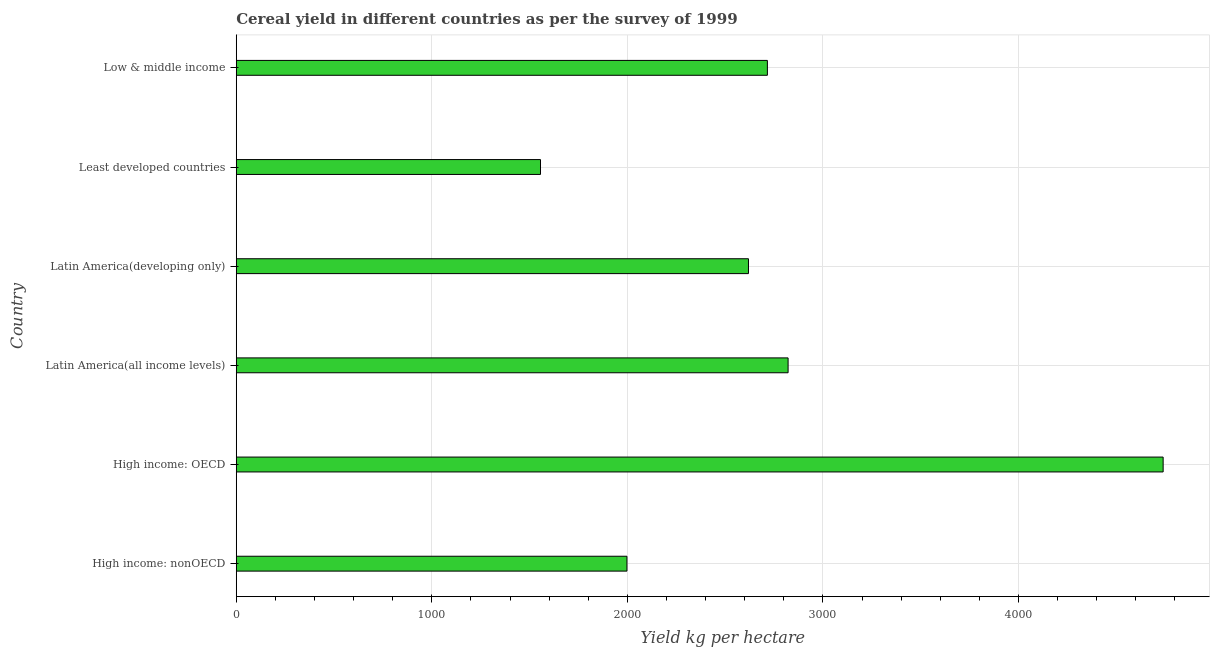What is the title of the graph?
Give a very brief answer. Cereal yield in different countries as per the survey of 1999. What is the label or title of the X-axis?
Your answer should be compact. Yield kg per hectare. What is the cereal yield in Latin America(developing only)?
Your response must be concise. 2619.43. Across all countries, what is the maximum cereal yield?
Ensure brevity in your answer.  4740.07. Across all countries, what is the minimum cereal yield?
Give a very brief answer. 1555.91. In which country was the cereal yield maximum?
Your answer should be very brief. High income: OECD. In which country was the cereal yield minimum?
Your answer should be very brief. Least developed countries. What is the sum of the cereal yield?
Your response must be concise. 1.65e+04. What is the difference between the cereal yield in High income: nonOECD and Latin America(developing only)?
Your response must be concise. -621.42. What is the average cereal yield per country?
Offer a terse response. 2741.94. What is the median cereal yield?
Ensure brevity in your answer.  2667.79. What is the ratio of the cereal yield in High income: OECD to that in High income: nonOECD?
Provide a short and direct response. 2.37. Is the difference between the cereal yield in Latin America(all income levels) and Least developed countries greater than the difference between any two countries?
Give a very brief answer. No. What is the difference between the highest and the second highest cereal yield?
Your response must be concise. 1917.99. What is the difference between the highest and the lowest cereal yield?
Provide a succinct answer. 3184.15. In how many countries, is the cereal yield greater than the average cereal yield taken over all countries?
Make the answer very short. 2. What is the difference between two consecutive major ticks on the X-axis?
Provide a succinct answer. 1000. Are the values on the major ticks of X-axis written in scientific E-notation?
Offer a terse response. No. What is the Yield kg per hectare in High income: nonOECD?
Provide a succinct answer. 1998.01. What is the Yield kg per hectare of High income: OECD?
Provide a succinct answer. 4740.07. What is the Yield kg per hectare in Latin America(all income levels)?
Provide a short and direct response. 2822.08. What is the Yield kg per hectare in Latin America(developing only)?
Keep it short and to the point. 2619.43. What is the Yield kg per hectare in Least developed countries?
Provide a succinct answer. 1555.91. What is the Yield kg per hectare of Low & middle income?
Your answer should be compact. 2716.16. What is the difference between the Yield kg per hectare in High income: nonOECD and High income: OECD?
Keep it short and to the point. -2742.06. What is the difference between the Yield kg per hectare in High income: nonOECD and Latin America(all income levels)?
Keep it short and to the point. -824.07. What is the difference between the Yield kg per hectare in High income: nonOECD and Latin America(developing only)?
Offer a terse response. -621.42. What is the difference between the Yield kg per hectare in High income: nonOECD and Least developed countries?
Offer a terse response. 442.09. What is the difference between the Yield kg per hectare in High income: nonOECD and Low & middle income?
Offer a terse response. -718.15. What is the difference between the Yield kg per hectare in High income: OECD and Latin America(all income levels)?
Offer a terse response. 1917.99. What is the difference between the Yield kg per hectare in High income: OECD and Latin America(developing only)?
Your response must be concise. 2120.64. What is the difference between the Yield kg per hectare in High income: OECD and Least developed countries?
Your response must be concise. 3184.15. What is the difference between the Yield kg per hectare in High income: OECD and Low & middle income?
Ensure brevity in your answer.  2023.91. What is the difference between the Yield kg per hectare in Latin America(all income levels) and Latin America(developing only)?
Ensure brevity in your answer.  202.65. What is the difference between the Yield kg per hectare in Latin America(all income levels) and Least developed countries?
Offer a terse response. 1266.17. What is the difference between the Yield kg per hectare in Latin America(all income levels) and Low & middle income?
Your answer should be compact. 105.92. What is the difference between the Yield kg per hectare in Latin America(developing only) and Least developed countries?
Offer a terse response. 1063.51. What is the difference between the Yield kg per hectare in Latin America(developing only) and Low & middle income?
Provide a short and direct response. -96.73. What is the difference between the Yield kg per hectare in Least developed countries and Low & middle income?
Give a very brief answer. -1160.24. What is the ratio of the Yield kg per hectare in High income: nonOECD to that in High income: OECD?
Your answer should be very brief. 0.42. What is the ratio of the Yield kg per hectare in High income: nonOECD to that in Latin America(all income levels)?
Your response must be concise. 0.71. What is the ratio of the Yield kg per hectare in High income: nonOECD to that in Latin America(developing only)?
Give a very brief answer. 0.76. What is the ratio of the Yield kg per hectare in High income: nonOECD to that in Least developed countries?
Give a very brief answer. 1.28. What is the ratio of the Yield kg per hectare in High income: nonOECD to that in Low & middle income?
Give a very brief answer. 0.74. What is the ratio of the Yield kg per hectare in High income: OECD to that in Latin America(all income levels)?
Provide a succinct answer. 1.68. What is the ratio of the Yield kg per hectare in High income: OECD to that in Latin America(developing only)?
Your response must be concise. 1.81. What is the ratio of the Yield kg per hectare in High income: OECD to that in Least developed countries?
Give a very brief answer. 3.05. What is the ratio of the Yield kg per hectare in High income: OECD to that in Low & middle income?
Offer a very short reply. 1.75. What is the ratio of the Yield kg per hectare in Latin America(all income levels) to that in Latin America(developing only)?
Offer a terse response. 1.08. What is the ratio of the Yield kg per hectare in Latin America(all income levels) to that in Least developed countries?
Ensure brevity in your answer.  1.81. What is the ratio of the Yield kg per hectare in Latin America(all income levels) to that in Low & middle income?
Offer a very short reply. 1.04. What is the ratio of the Yield kg per hectare in Latin America(developing only) to that in Least developed countries?
Your response must be concise. 1.68. What is the ratio of the Yield kg per hectare in Latin America(developing only) to that in Low & middle income?
Your answer should be very brief. 0.96. What is the ratio of the Yield kg per hectare in Least developed countries to that in Low & middle income?
Give a very brief answer. 0.57. 